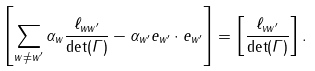<formula> <loc_0><loc_0><loc_500><loc_500>\left [ \sum _ { w \neq w ^ { \prime } } \alpha _ { w } \frac { \ell _ { w w ^ { \prime } } } { \det ( \Gamma ) } - \alpha _ { w ^ { \prime } } e _ { w ^ { \prime } } \cdot e _ { w ^ { \prime } } \right ] = \left [ \frac { \ell _ { v w ^ { \prime } } } { \det ( \Gamma ) } \right ] .</formula> 